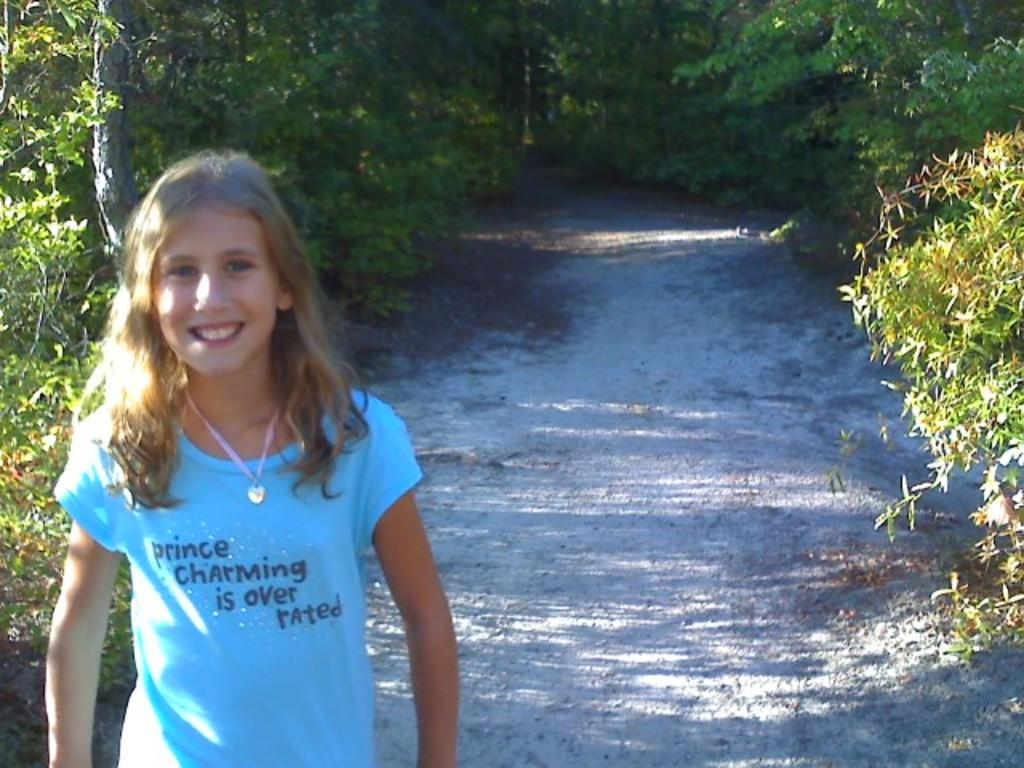What is the main feature of the image? There is a path in the image. What can be seen around the path? The path is surrounded by trees. Where is the kid located in the image? The kid is in the bottom left of the image. What is the kid wearing? The kid is wearing clothes. What type of addition problem can be solved using the trees in the image? There is no addition problem present in the image, as it features a path surrounded by trees and a kid. 